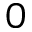<formula> <loc_0><loc_0><loc_500><loc_500>0</formula> 